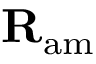Convert formula to latex. <formula><loc_0><loc_0><loc_500><loc_500>{ R } _ { a m }</formula> 